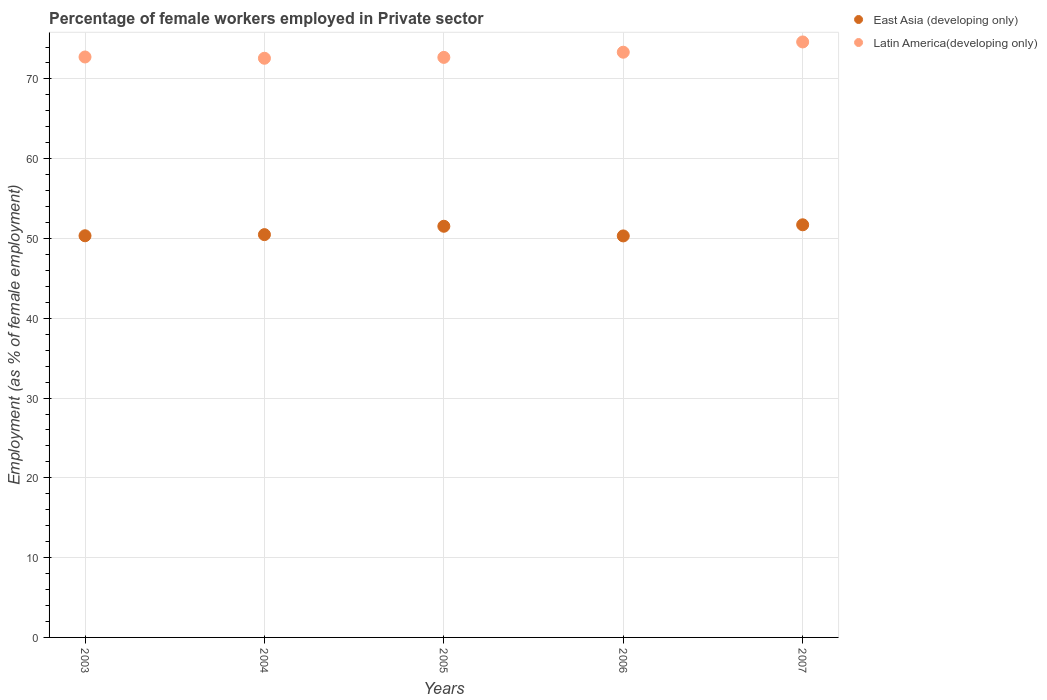What is the percentage of females employed in Private sector in Latin America(developing only) in 2005?
Offer a very short reply. 72.7. Across all years, what is the maximum percentage of females employed in Private sector in East Asia (developing only)?
Provide a short and direct response. 51.72. Across all years, what is the minimum percentage of females employed in Private sector in East Asia (developing only)?
Give a very brief answer. 50.32. In which year was the percentage of females employed in Private sector in Latin America(developing only) maximum?
Your answer should be very brief. 2007. In which year was the percentage of females employed in Private sector in Latin America(developing only) minimum?
Offer a terse response. 2004. What is the total percentage of females employed in Private sector in East Asia (developing only) in the graph?
Make the answer very short. 254.41. What is the difference between the percentage of females employed in Private sector in Latin America(developing only) in 2004 and that in 2007?
Offer a terse response. -2.04. What is the difference between the percentage of females employed in Private sector in Latin America(developing only) in 2004 and the percentage of females employed in Private sector in East Asia (developing only) in 2003?
Your answer should be very brief. 22.25. What is the average percentage of females employed in Private sector in East Asia (developing only) per year?
Provide a short and direct response. 50.88. In the year 2004, what is the difference between the percentage of females employed in Private sector in East Asia (developing only) and percentage of females employed in Private sector in Latin America(developing only)?
Your answer should be compact. -22.11. In how many years, is the percentage of females employed in Private sector in Latin America(developing only) greater than 56 %?
Offer a terse response. 5. What is the ratio of the percentage of females employed in Private sector in Latin America(developing only) in 2003 to that in 2004?
Your answer should be very brief. 1. Is the difference between the percentage of females employed in Private sector in East Asia (developing only) in 2003 and 2007 greater than the difference between the percentage of females employed in Private sector in Latin America(developing only) in 2003 and 2007?
Offer a terse response. Yes. What is the difference between the highest and the second highest percentage of females employed in Private sector in East Asia (developing only)?
Offer a terse response. 0.18. What is the difference between the highest and the lowest percentage of females employed in Private sector in East Asia (developing only)?
Your response must be concise. 1.39. In how many years, is the percentage of females employed in Private sector in Latin America(developing only) greater than the average percentage of females employed in Private sector in Latin America(developing only) taken over all years?
Provide a short and direct response. 2. Is the sum of the percentage of females employed in Private sector in East Asia (developing only) in 2005 and 2007 greater than the maximum percentage of females employed in Private sector in Latin America(developing only) across all years?
Ensure brevity in your answer.  Yes. How many dotlines are there?
Give a very brief answer. 2. How many years are there in the graph?
Provide a short and direct response. 5. How many legend labels are there?
Offer a very short reply. 2. How are the legend labels stacked?
Offer a very short reply. Vertical. What is the title of the graph?
Keep it short and to the point. Percentage of female workers employed in Private sector. Does "Serbia" appear as one of the legend labels in the graph?
Offer a terse response. No. What is the label or title of the Y-axis?
Your answer should be compact. Employment (as % of female employment). What is the Employment (as % of female employment) in East Asia (developing only) in 2003?
Offer a terse response. 50.34. What is the Employment (as % of female employment) of Latin America(developing only) in 2003?
Provide a short and direct response. 72.75. What is the Employment (as % of female employment) in East Asia (developing only) in 2004?
Offer a terse response. 50.49. What is the Employment (as % of female employment) of Latin America(developing only) in 2004?
Give a very brief answer. 72.59. What is the Employment (as % of female employment) in East Asia (developing only) in 2005?
Make the answer very short. 51.54. What is the Employment (as % of female employment) in Latin America(developing only) in 2005?
Your response must be concise. 72.7. What is the Employment (as % of female employment) in East Asia (developing only) in 2006?
Keep it short and to the point. 50.32. What is the Employment (as % of female employment) of Latin America(developing only) in 2006?
Ensure brevity in your answer.  73.35. What is the Employment (as % of female employment) in East Asia (developing only) in 2007?
Keep it short and to the point. 51.72. What is the Employment (as % of female employment) in Latin America(developing only) in 2007?
Give a very brief answer. 74.64. Across all years, what is the maximum Employment (as % of female employment) of East Asia (developing only)?
Offer a terse response. 51.72. Across all years, what is the maximum Employment (as % of female employment) in Latin America(developing only)?
Make the answer very short. 74.64. Across all years, what is the minimum Employment (as % of female employment) of East Asia (developing only)?
Your answer should be very brief. 50.32. Across all years, what is the minimum Employment (as % of female employment) of Latin America(developing only)?
Your response must be concise. 72.59. What is the total Employment (as % of female employment) of East Asia (developing only) in the graph?
Provide a short and direct response. 254.41. What is the total Employment (as % of female employment) in Latin America(developing only) in the graph?
Keep it short and to the point. 366.03. What is the difference between the Employment (as % of female employment) of East Asia (developing only) in 2003 and that in 2004?
Ensure brevity in your answer.  -0.14. What is the difference between the Employment (as % of female employment) of Latin America(developing only) in 2003 and that in 2004?
Your answer should be compact. 0.16. What is the difference between the Employment (as % of female employment) of East Asia (developing only) in 2003 and that in 2005?
Give a very brief answer. -1.19. What is the difference between the Employment (as % of female employment) of Latin America(developing only) in 2003 and that in 2005?
Provide a short and direct response. 0.05. What is the difference between the Employment (as % of female employment) of East Asia (developing only) in 2003 and that in 2006?
Give a very brief answer. 0.02. What is the difference between the Employment (as % of female employment) in Latin America(developing only) in 2003 and that in 2006?
Your answer should be compact. -0.6. What is the difference between the Employment (as % of female employment) of East Asia (developing only) in 2003 and that in 2007?
Offer a terse response. -1.37. What is the difference between the Employment (as % of female employment) of Latin America(developing only) in 2003 and that in 2007?
Give a very brief answer. -1.88. What is the difference between the Employment (as % of female employment) of East Asia (developing only) in 2004 and that in 2005?
Provide a succinct answer. -1.05. What is the difference between the Employment (as % of female employment) in Latin America(developing only) in 2004 and that in 2005?
Make the answer very short. -0.11. What is the difference between the Employment (as % of female employment) of East Asia (developing only) in 2004 and that in 2006?
Keep it short and to the point. 0.16. What is the difference between the Employment (as % of female employment) in Latin America(developing only) in 2004 and that in 2006?
Your response must be concise. -0.76. What is the difference between the Employment (as % of female employment) of East Asia (developing only) in 2004 and that in 2007?
Your answer should be compact. -1.23. What is the difference between the Employment (as % of female employment) in Latin America(developing only) in 2004 and that in 2007?
Provide a succinct answer. -2.04. What is the difference between the Employment (as % of female employment) in East Asia (developing only) in 2005 and that in 2006?
Give a very brief answer. 1.21. What is the difference between the Employment (as % of female employment) in Latin America(developing only) in 2005 and that in 2006?
Offer a very short reply. -0.65. What is the difference between the Employment (as % of female employment) in East Asia (developing only) in 2005 and that in 2007?
Give a very brief answer. -0.18. What is the difference between the Employment (as % of female employment) of Latin America(developing only) in 2005 and that in 2007?
Offer a terse response. -1.93. What is the difference between the Employment (as % of female employment) of East Asia (developing only) in 2006 and that in 2007?
Ensure brevity in your answer.  -1.39. What is the difference between the Employment (as % of female employment) in Latin America(developing only) in 2006 and that in 2007?
Ensure brevity in your answer.  -1.29. What is the difference between the Employment (as % of female employment) in East Asia (developing only) in 2003 and the Employment (as % of female employment) in Latin America(developing only) in 2004?
Provide a short and direct response. -22.25. What is the difference between the Employment (as % of female employment) of East Asia (developing only) in 2003 and the Employment (as % of female employment) of Latin America(developing only) in 2005?
Give a very brief answer. -22.36. What is the difference between the Employment (as % of female employment) in East Asia (developing only) in 2003 and the Employment (as % of female employment) in Latin America(developing only) in 2006?
Your answer should be very brief. -23.01. What is the difference between the Employment (as % of female employment) of East Asia (developing only) in 2003 and the Employment (as % of female employment) of Latin America(developing only) in 2007?
Ensure brevity in your answer.  -24.29. What is the difference between the Employment (as % of female employment) in East Asia (developing only) in 2004 and the Employment (as % of female employment) in Latin America(developing only) in 2005?
Your response must be concise. -22.22. What is the difference between the Employment (as % of female employment) in East Asia (developing only) in 2004 and the Employment (as % of female employment) in Latin America(developing only) in 2006?
Offer a terse response. -22.86. What is the difference between the Employment (as % of female employment) in East Asia (developing only) in 2004 and the Employment (as % of female employment) in Latin America(developing only) in 2007?
Provide a succinct answer. -24.15. What is the difference between the Employment (as % of female employment) of East Asia (developing only) in 2005 and the Employment (as % of female employment) of Latin America(developing only) in 2006?
Ensure brevity in your answer.  -21.81. What is the difference between the Employment (as % of female employment) in East Asia (developing only) in 2005 and the Employment (as % of female employment) in Latin America(developing only) in 2007?
Your answer should be very brief. -23.1. What is the difference between the Employment (as % of female employment) in East Asia (developing only) in 2006 and the Employment (as % of female employment) in Latin America(developing only) in 2007?
Offer a very short reply. -24.31. What is the average Employment (as % of female employment) of East Asia (developing only) per year?
Ensure brevity in your answer.  50.88. What is the average Employment (as % of female employment) in Latin America(developing only) per year?
Provide a short and direct response. 73.21. In the year 2003, what is the difference between the Employment (as % of female employment) in East Asia (developing only) and Employment (as % of female employment) in Latin America(developing only)?
Provide a short and direct response. -22.41. In the year 2004, what is the difference between the Employment (as % of female employment) of East Asia (developing only) and Employment (as % of female employment) of Latin America(developing only)?
Your response must be concise. -22.11. In the year 2005, what is the difference between the Employment (as % of female employment) in East Asia (developing only) and Employment (as % of female employment) in Latin America(developing only)?
Your response must be concise. -21.17. In the year 2006, what is the difference between the Employment (as % of female employment) in East Asia (developing only) and Employment (as % of female employment) in Latin America(developing only)?
Your answer should be very brief. -23.03. In the year 2007, what is the difference between the Employment (as % of female employment) in East Asia (developing only) and Employment (as % of female employment) in Latin America(developing only)?
Make the answer very short. -22.92. What is the ratio of the Employment (as % of female employment) in East Asia (developing only) in 2003 to that in 2004?
Your response must be concise. 1. What is the ratio of the Employment (as % of female employment) of Latin America(developing only) in 2003 to that in 2004?
Offer a very short reply. 1. What is the ratio of the Employment (as % of female employment) in East Asia (developing only) in 2003 to that in 2005?
Ensure brevity in your answer.  0.98. What is the ratio of the Employment (as % of female employment) of Latin America(developing only) in 2003 to that in 2005?
Provide a short and direct response. 1. What is the ratio of the Employment (as % of female employment) of East Asia (developing only) in 2003 to that in 2007?
Provide a succinct answer. 0.97. What is the ratio of the Employment (as % of female employment) in Latin America(developing only) in 2003 to that in 2007?
Make the answer very short. 0.97. What is the ratio of the Employment (as % of female employment) in East Asia (developing only) in 2004 to that in 2005?
Offer a very short reply. 0.98. What is the ratio of the Employment (as % of female employment) of East Asia (developing only) in 2004 to that in 2006?
Provide a succinct answer. 1. What is the ratio of the Employment (as % of female employment) of Latin America(developing only) in 2004 to that in 2006?
Your answer should be compact. 0.99. What is the ratio of the Employment (as % of female employment) in East Asia (developing only) in 2004 to that in 2007?
Give a very brief answer. 0.98. What is the ratio of the Employment (as % of female employment) in Latin America(developing only) in 2004 to that in 2007?
Give a very brief answer. 0.97. What is the ratio of the Employment (as % of female employment) of East Asia (developing only) in 2005 to that in 2006?
Provide a short and direct response. 1.02. What is the ratio of the Employment (as % of female employment) in Latin America(developing only) in 2005 to that in 2006?
Give a very brief answer. 0.99. What is the ratio of the Employment (as % of female employment) of East Asia (developing only) in 2005 to that in 2007?
Your answer should be very brief. 1. What is the ratio of the Employment (as % of female employment) of Latin America(developing only) in 2005 to that in 2007?
Keep it short and to the point. 0.97. What is the ratio of the Employment (as % of female employment) of East Asia (developing only) in 2006 to that in 2007?
Keep it short and to the point. 0.97. What is the ratio of the Employment (as % of female employment) of Latin America(developing only) in 2006 to that in 2007?
Provide a short and direct response. 0.98. What is the difference between the highest and the second highest Employment (as % of female employment) in East Asia (developing only)?
Your answer should be very brief. 0.18. What is the difference between the highest and the second highest Employment (as % of female employment) in Latin America(developing only)?
Offer a very short reply. 1.29. What is the difference between the highest and the lowest Employment (as % of female employment) of East Asia (developing only)?
Your answer should be very brief. 1.39. What is the difference between the highest and the lowest Employment (as % of female employment) of Latin America(developing only)?
Provide a succinct answer. 2.04. 